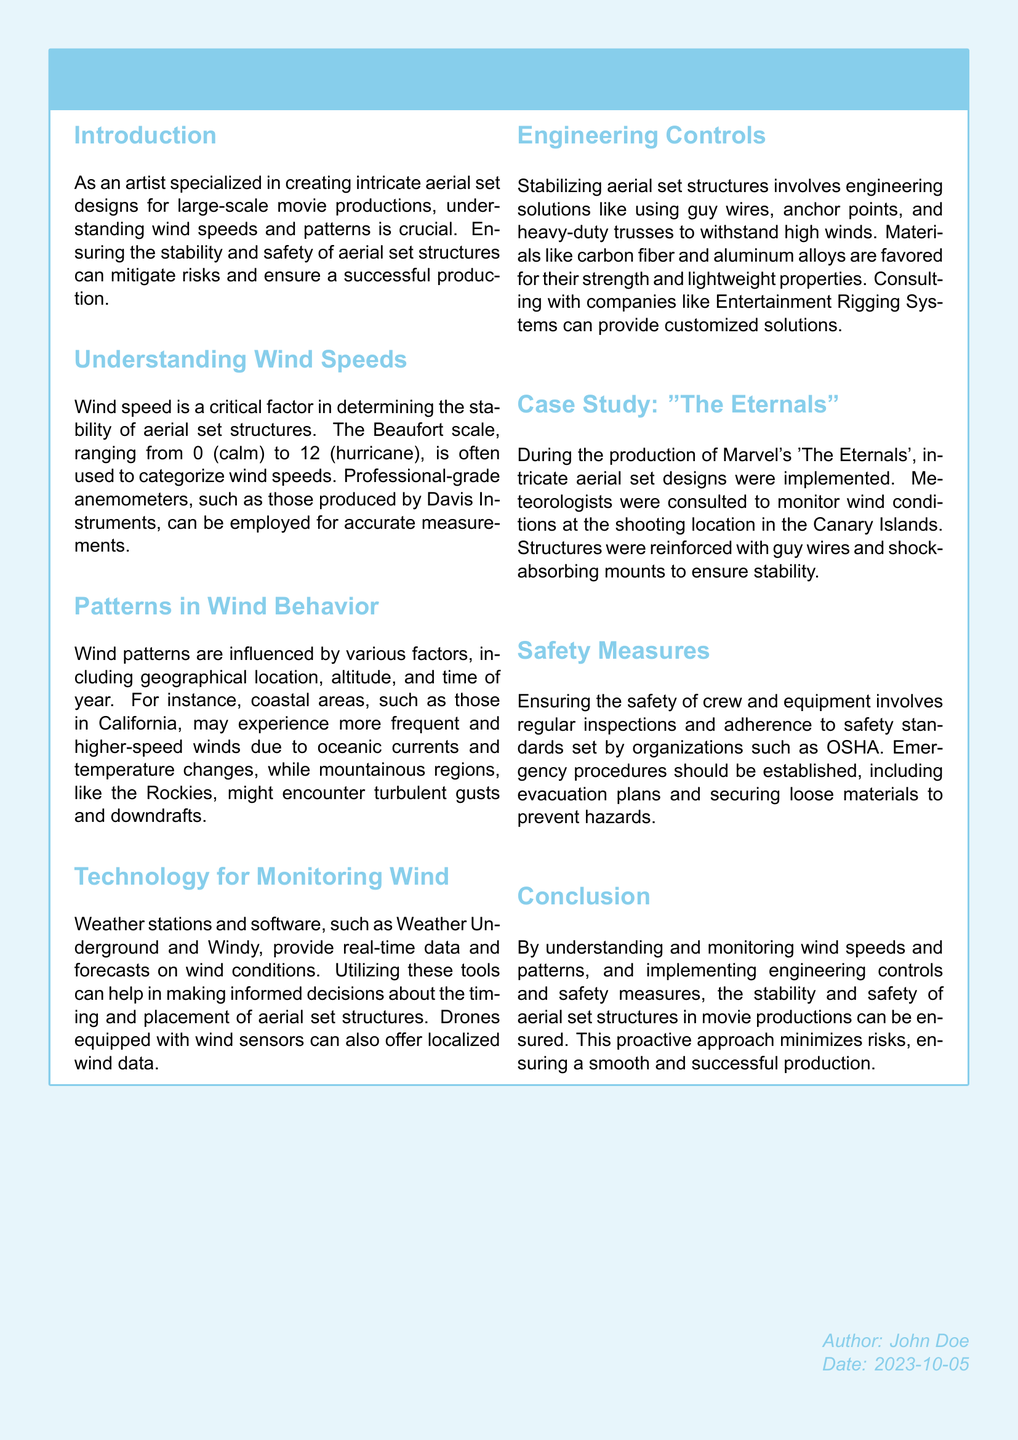What is the title of the document? The title is stated prominently in the tcolorbox at the beginning of the document.
Answer: Wind Speeds and Patterns: Ensuring Stability and Safety for Aerial Set Structures What scale is used to categorize wind speeds? The document mentions the Beaufort scale, which categorizes wind speeds.
Answer: Beaufort scale What is the highest level on the Beaufort scale? The document indicates the range of the Beaufort scale, with the highest level being 12, which is a hurricane.
Answer: 12 Which geographical area is mentioned as experiencing higher wind speeds? The coastal areas like California are highlighted for their wind conditions.
Answer: California What material is favored for its strength and lightweight properties? The document lists carbon fiber and aluminum alloys as preferred materials for aerial set structures.
Answer: Carbon fiber and aluminum alloys What was a safety measure taken during the production of "The Eternals"? The document cites the use of guy wires and shock-absorbing mounts for stability.
Answer: Guy wires and shock-absorbing mounts What technology is suggested for monitoring wind in real-time? The document recommends weather stations and software like Weather Underground and Windy for real-time data.
Answer: Weather Underground and Windy Who is the author of the document? The author is mentioned at the bottom of the document.
Answer: John Doe What should be established to ensure crew safety? The document suggests that emergency procedures must be established for safety.
Answer: Emergency procedures 